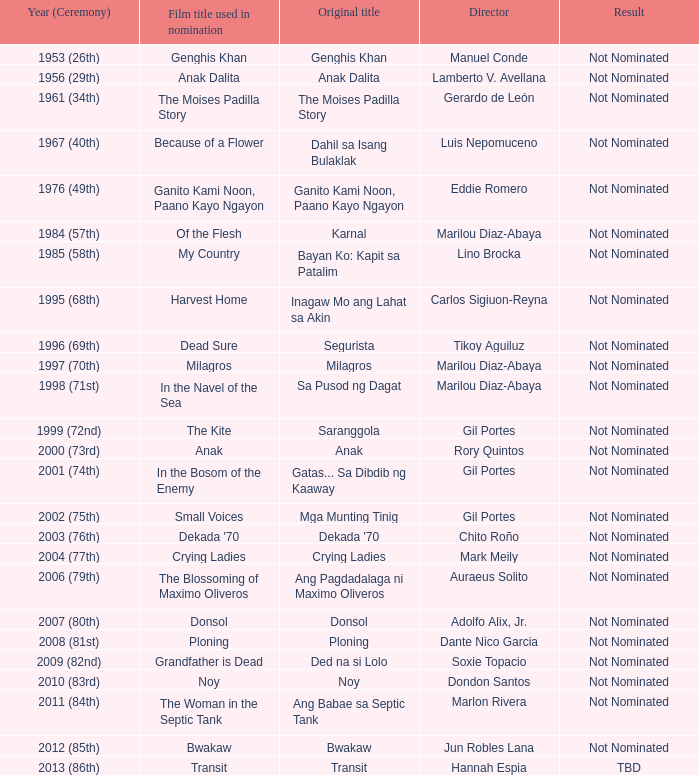Who was the director of small voices, a film name used in nomination? Gil Portes. 